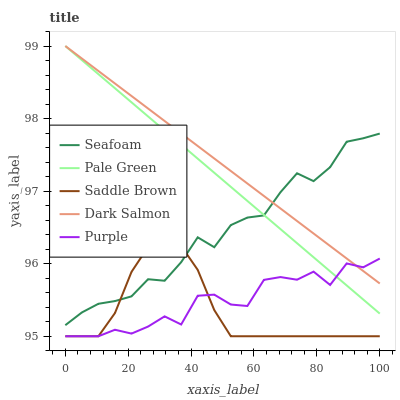Does Saddle Brown have the minimum area under the curve?
Answer yes or no. Yes. Does Dark Salmon have the maximum area under the curve?
Answer yes or no. Yes. Does Pale Green have the minimum area under the curve?
Answer yes or no. No. Does Pale Green have the maximum area under the curve?
Answer yes or no. No. Is Dark Salmon the smoothest?
Answer yes or no. Yes. Is Purple the roughest?
Answer yes or no. Yes. Is Pale Green the smoothest?
Answer yes or no. No. Is Pale Green the roughest?
Answer yes or no. No. Does Purple have the lowest value?
Answer yes or no. Yes. Does Pale Green have the lowest value?
Answer yes or no. No. Does Dark Salmon have the highest value?
Answer yes or no. Yes. Does Seafoam have the highest value?
Answer yes or no. No. Is Saddle Brown less than Pale Green?
Answer yes or no. Yes. Is Pale Green greater than Saddle Brown?
Answer yes or no. Yes. Does Dark Salmon intersect Seafoam?
Answer yes or no. Yes. Is Dark Salmon less than Seafoam?
Answer yes or no. No. Is Dark Salmon greater than Seafoam?
Answer yes or no. No. Does Saddle Brown intersect Pale Green?
Answer yes or no. No. 